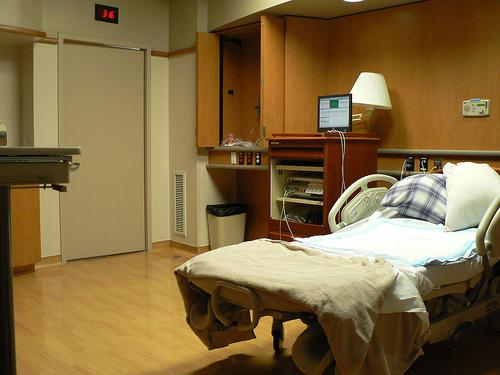Question: where is the red numbers?
Choices:
A. Above door.
B. On the street.
C. Above the desk.
D. On the player's uniform.
Answer with the letter. Answer: A Question: what type of flooring is in room?
Choices:
A. Carpeting.
B. Wooden.
C. Tile.
D. Concrete.
Answer with the letter. Answer: B Question: where was the photo taken?
Choices:
A. Hospital room.
B. Circus.
C. Beach.
D. Classroom.
Answer with the letter. Answer: A Question: what color is the door?
Choices:
A. Red.
B. White.
C. Green.
D. Tan.
Answer with the letter. Answer: D Question: what can be slept on?
Choices:
A. Hospital bed.
B. Bench.
C. Couch.
D. Recliner.
Answer with the letter. Answer: A 